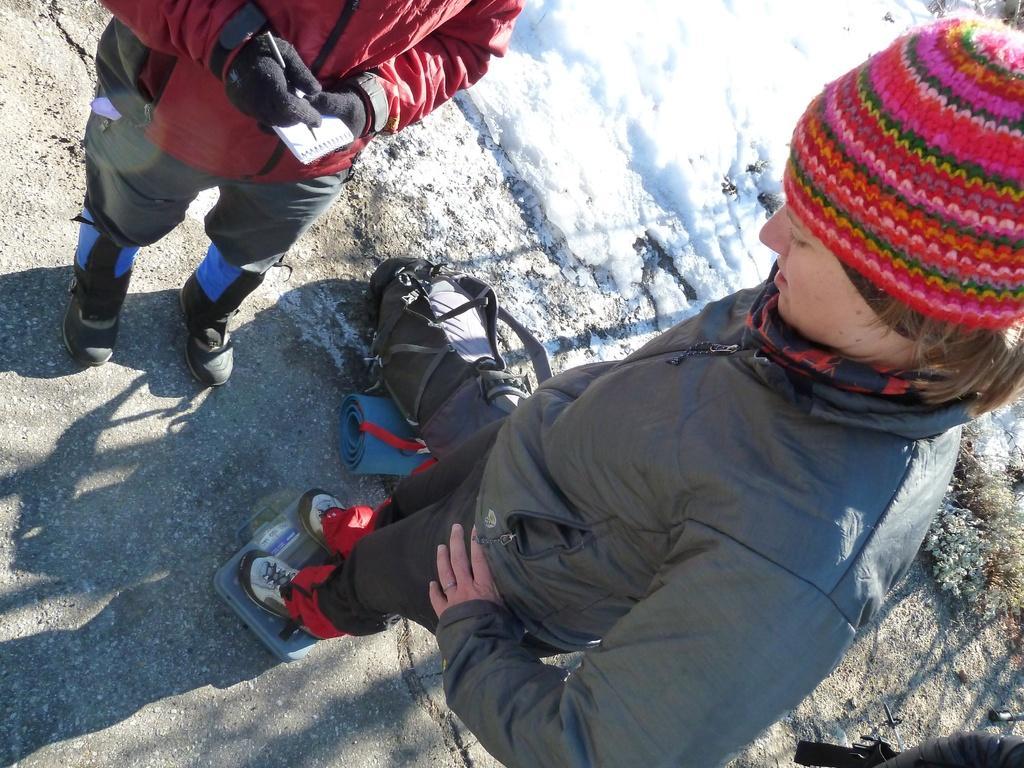How would you summarize this image in a sentence or two? In this picture, we can see a few people, and among them we can see a person holding some objects, and we can see the ground with snow, and we can see some objects like weighing machine, bags, mats, and plants. 